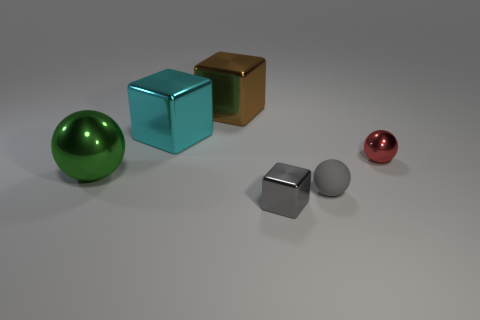Could you infer the possible materials these objects might be made of? Based on their appearance, the objects could be made of various materials: the reflective sphere likely a polished metal, the cubes might be anodized aluminum or painted wood, and the smaller, less reflective sphere looks like it could be a matte plastic. 